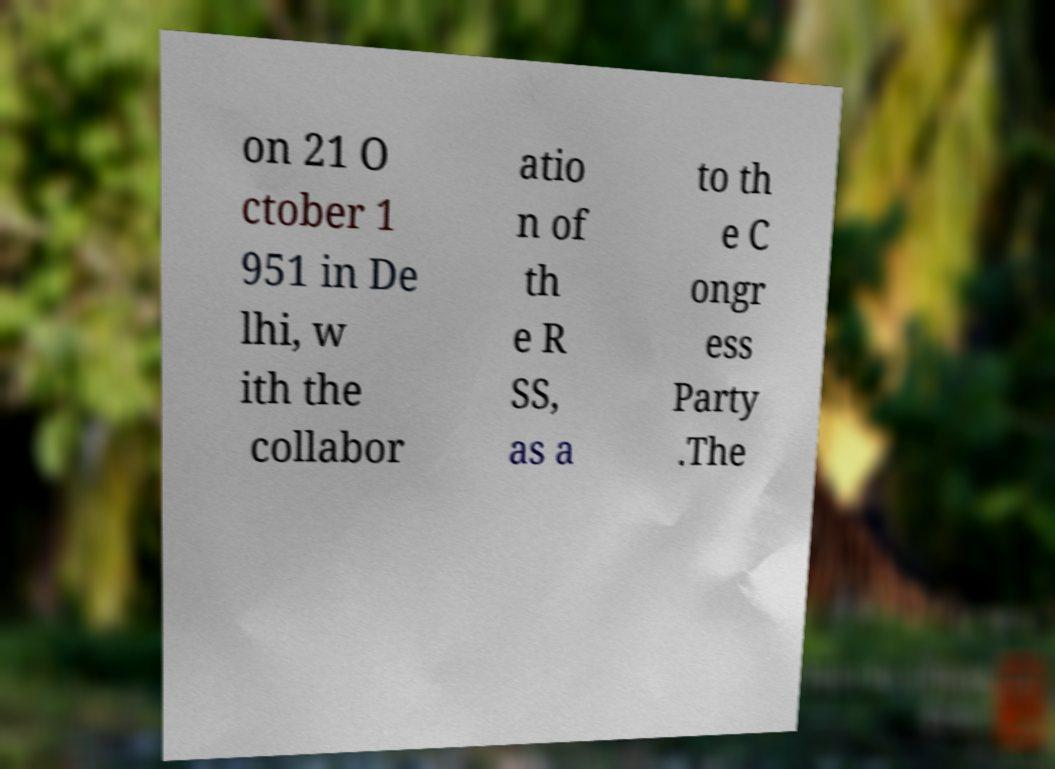Can you accurately transcribe the text from the provided image for me? on 21 O ctober 1 951 in De lhi, w ith the collabor atio n of th e R SS, as a to th e C ongr ess Party .The 